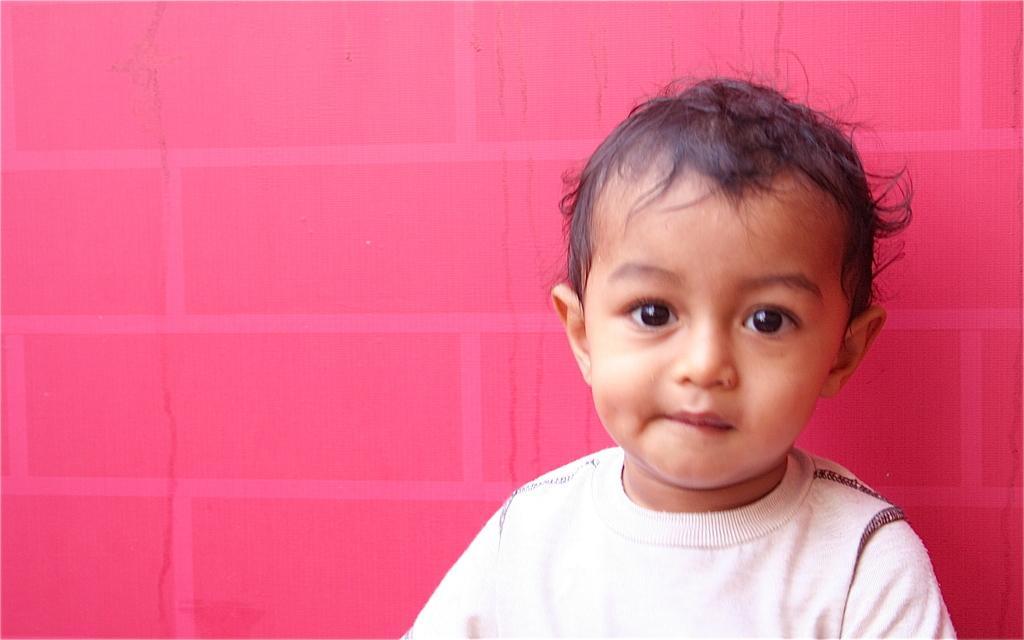In one or two sentences, can you explain what this image depicts? In this picture there is a boy who is wearing white t-shirt. At the back there is a red wall. 